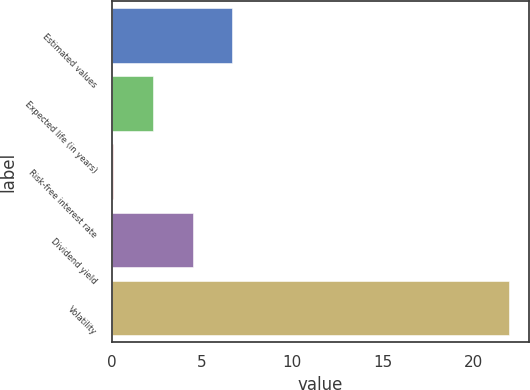Convert chart to OTSL. <chart><loc_0><loc_0><loc_500><loc_500><bar_chart><fcel>Estimated values<fcel>Expected life (in years)<fcel>Risk-free interest rate<fcel>Dividend yield<fcel>Volatility<nl><fcel>6.67<fcel>2.29<fcel>0.1<fcel>4.48<fcel>22<nl></chart> 